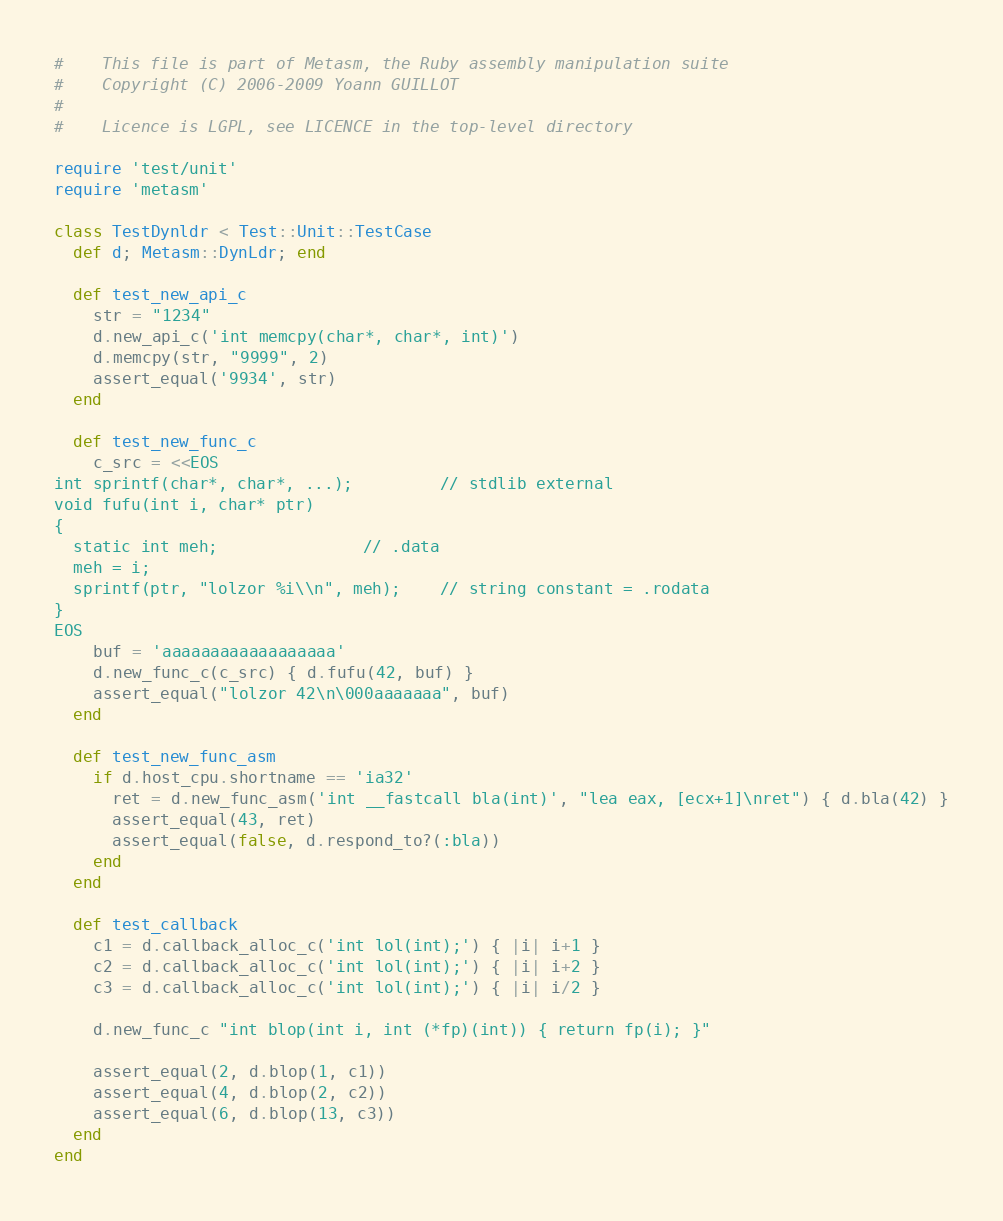Convert code to text. <code><loc_0><loc_0><loc_500><loc_500><_Ruby_>#    This file is part of Metasm, the Ruby assembly manipulation suite
#    Copyright (C) 2006-2009 Yoann GUILLOT
#
#    Licence is LGPL, see LICENCE in the top-level directory

require 'test/unit'
require 'metasm'

class TestDynldr < Test::Unit::TestCase
  def d; Metasm::DynLdr; end

  def test_new_api_c
    str = "1234"
    d.new_api_c('int memcpy(char*, char*, int)')
    d.memcpy(str, "9999", 2)
    assert_equal('9934', str)
  end

  def test_new_func_c
    c_src = <<EOS
int sprintf(char*, char*, ...);			// stdlib external
void fufu(int i, char* ptr)
{
  static int meh;				// .data
  meh = i;
  sprintf(ptr, "lolzor %i\\n", meh);	// string constant = .rodata
}
EOS
    buf = 'aaaaaaaaaaaaaaaaaa'
    d.new_func_c(c_src) { d.fufu(42, buf) }
    assert_equal("lolzor 42\n\000aaaaaaa", buf)
  end

  def test_new_func_asm
    if d.host_cpu.shortname == 'ia32'
      ret = d.new_func_asm('int __fastcall bla(int)', "lea eax, [ecx+1]\nret") { d.bla(42) }
      assert_equal(43, ret)
      assert_equal(false, d.respond_to?(:bla))
    end
  end

  def test_callback
    c1 = d.callback_alloc_c('int lol(int);') { |i| i+1 }
    c2 = d.callback_alloc_c('int lol(int);') { |i| i+2 }
    c3 = d.callback_alloc_c('int lol(int);') { |i| i/2 }

    d.new_func_c "int blop(int i, int (*fp)(int)) { return fp(i); }"
    
    assert_equal(2, d.blop(1, c1))
    assert_equal(4, d.blop(2, c2))
    assert_equal(6, d.blop(13, c3))
  end
end
</code> 